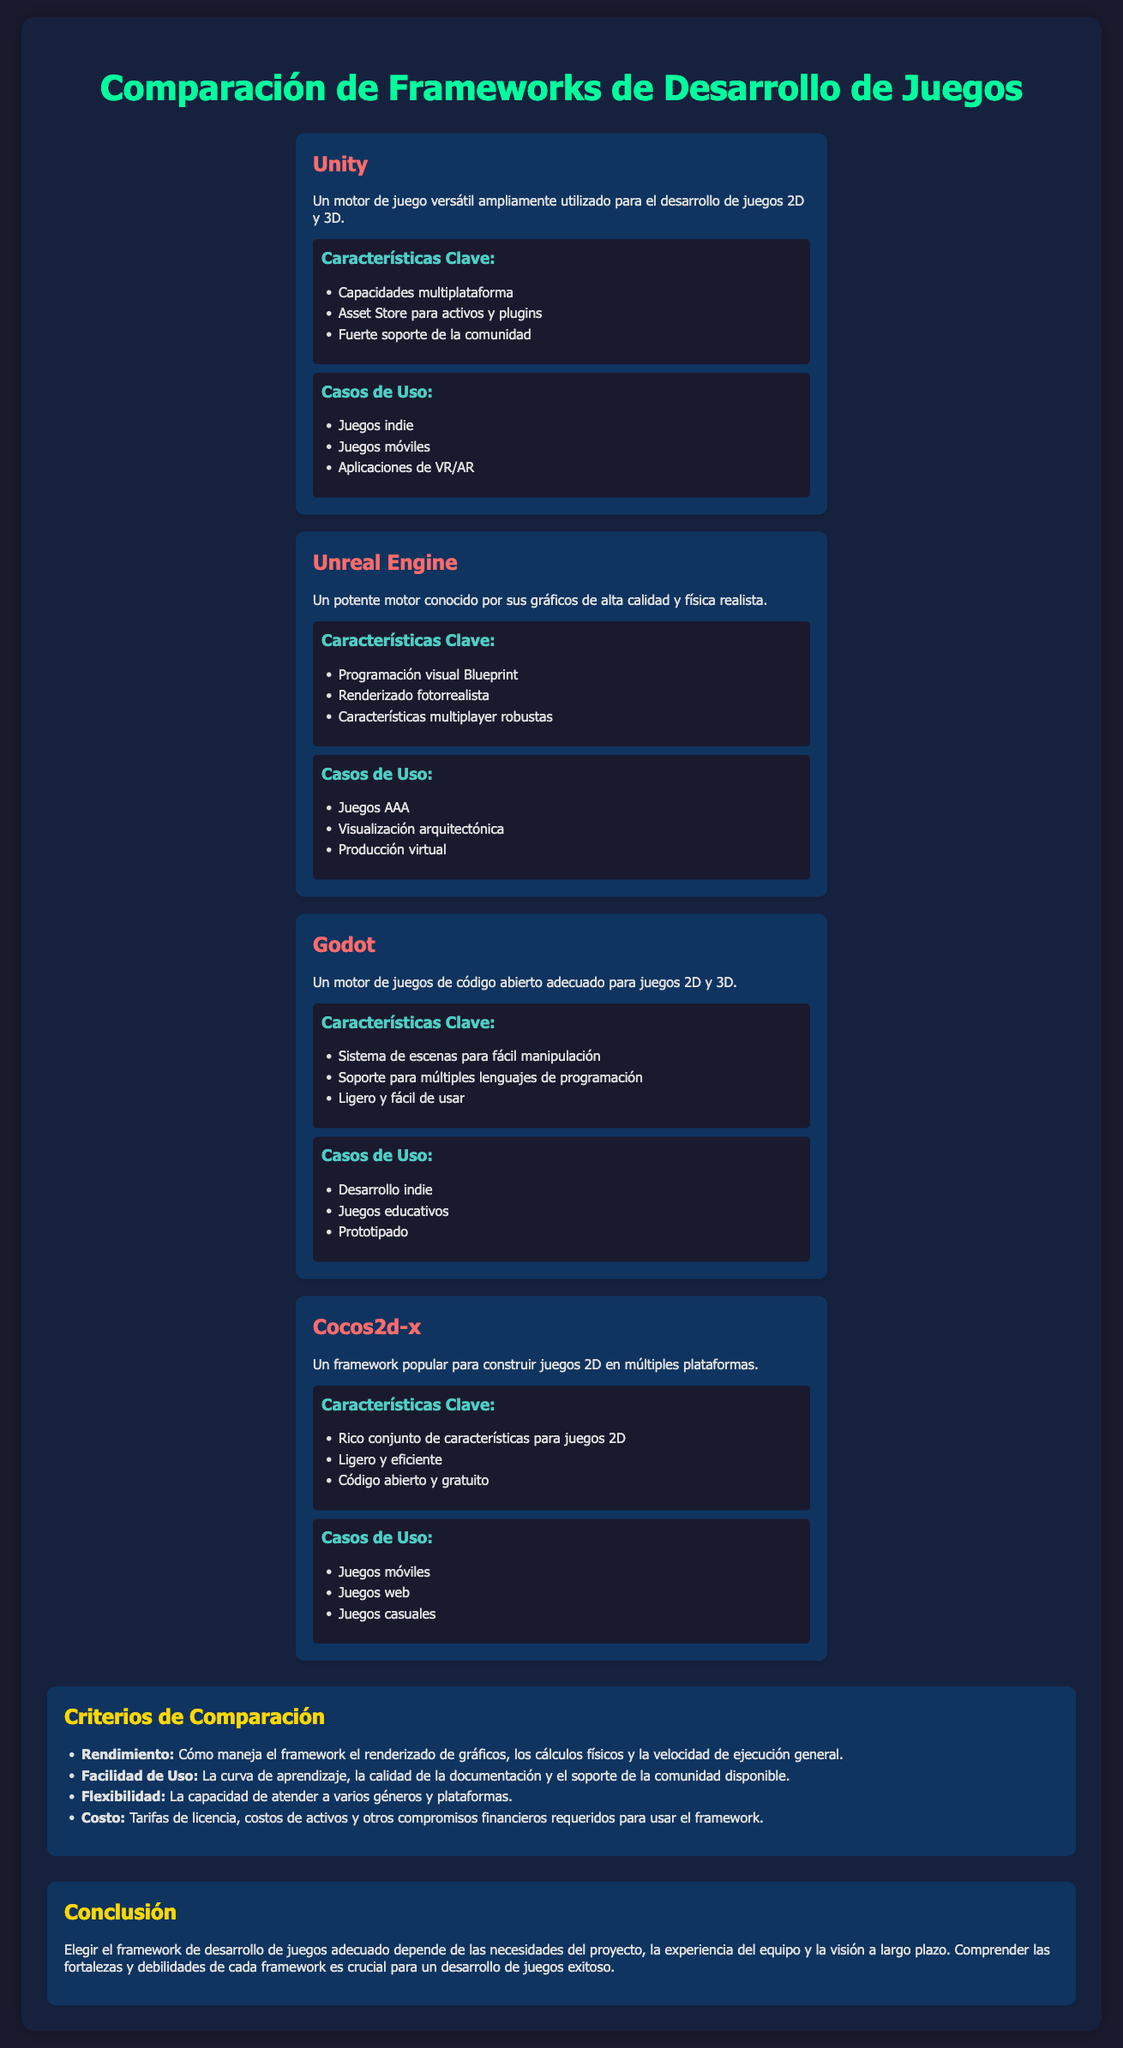¿Qué motor es conocido por sus gráficos de alta calidad? El motor mencionado en el documento que es conocido por sus gráficos de alta calidad es Unreal Engine.
Answer: Unreal Engine ¿Cuáles son las características clave de Godot? Se pueden encontrar las características clave de Godot en la sección correspondiente y son: Sistema de escenas para fácil manipulación, Soporte para múltiples lenguajes de programación, Ligero y fácil de usar.
Answer: Sistema de escenas para fácil manipulación ¿Para qué tipo de juegos es más utilizado Unity? En la sección de casos de uso para Unity se mencionan varios tipos, y uno de ellos es juegos indie.
Answer: Juegos indie ¿Cuál es uno de los casos de uso de Cocos2d-x? Se menciona en los casos de uso que Cocos2d-x es utilizado para juegos móviles.
Answer: Juegos móviles ¿Qué criterio de comparación se refiere a la curva de aprendizaje? La facilidad de uso es el criterio que se relaciona con la curva de aprendizaje en el documento.
Answer: Facilidad de Uso ¿Cuántos frameworks se comparan en el documento? El documento incluye un recuento de frameworks y se mencionan cuatro: Unity, Unreal Engine, Godot y Cocos2d-x.
Answer: Cuatro ¿Qué tipo de juegos se desarrollan más comúnmente con Unreal Engine? En los casos de uso para Unreal Engine, se indica que este motor es utilizado para juegos AAA.
Answer: Juegos AAA ¿Qué motor de desarrollo es descrito como de código abierto? En el documento, Godot se describe como un motor de juegos de código abierto.
Answer: Godot ¿Cuál es la conclusión principal del documento? La conclusión menciona que elegir el framework adecuado depende de las necesidades del proyecto, la experiencia del equipo y la visión a largo plazo.
Answer: Necesidades del proyecto 